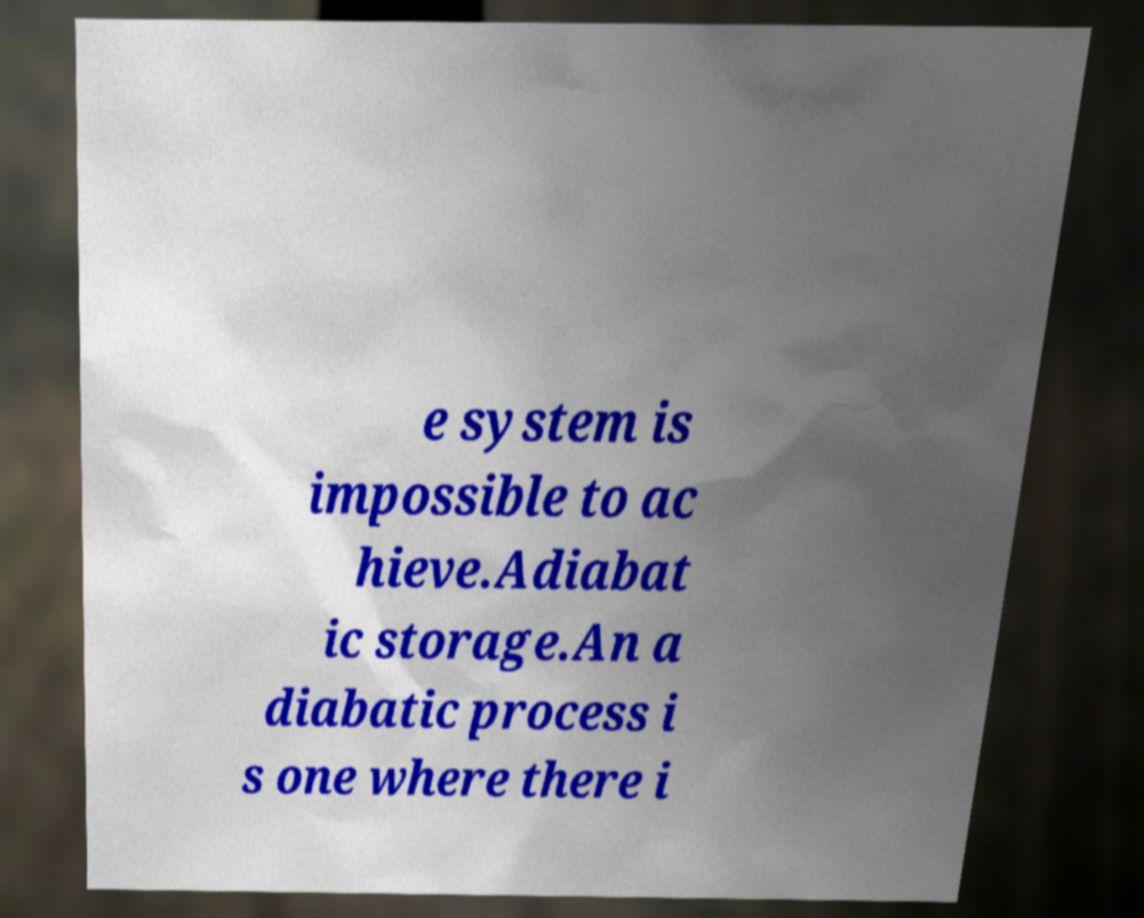Please read and relay the text visible in this image. What does it say? e system is impossible to ac hieve.Adiabat ic storage.An a diabatic process i s one where there i 